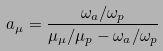Convert formula to latex. <formula><loc_0><loc_0><loc_500><loc_500>a _ { \mu } = \frac { \omega _ { a } / \omega _ { p } } { \mu _ { \mu } / \mu _ { p } - \omega _ { a } / \omega _ { p } }</formula> 